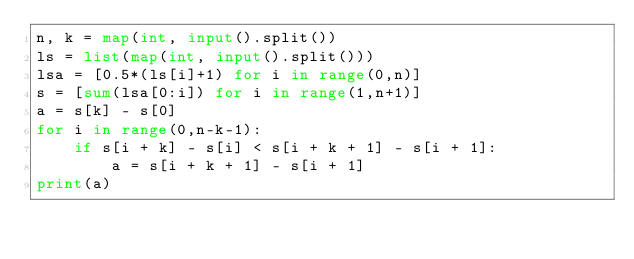<code> <loc_0><loc_0><loc_500><loc_500><_Python_>n, k = map(int, input().split())
ls = list(map(int, input().split()))
lsa = [0.5*(ls[i]+1) for i in range(0,n)]
s = [sum(lsa[0:i]) for i in range(1,n+1)]
a = s[k] - s[0]
for i in range(0,n-k-1):
    if s[i + k] - s[i] < s[i + k + 1] - s[i + 1]:
        a = s[i + k + 1] - s[i + 1]
print(a)
</code> 